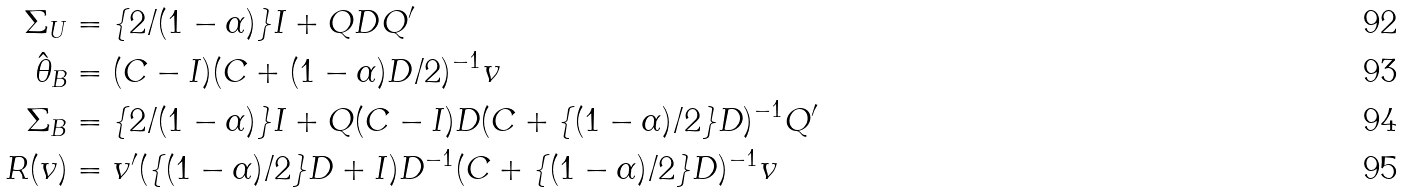<formula> <loc_0><loc_0><loc_500><loc_500>\Sigma _ { U } & = \{ 2 / ( 1 - \alpha ) \} I + Q D Q ^ { \prime } \\ \hat { \theta } _ { B } & = ( C - I ) ( C + ( 1 - \alpha ) D / 2 ) ^ { - 1 } v \\ \Sigma _ { B } & = \{ 2 / ( 1 - \alpha ) \} I + Q ( C - I ) D ( C + \{ ( 1 - \alpha ) / 2 \} D ) ^ { - 1 } Q ^ { \prime } \\ R ( v ) & = v ^ { \prime } ( \{ ( 1 - \alpha ) / 2 \} D + I ) D ^ { - 1 } ( C + \{ ( 1 - \alpha ) / 2 \} D ) ^ { - 1 } v</formula> 